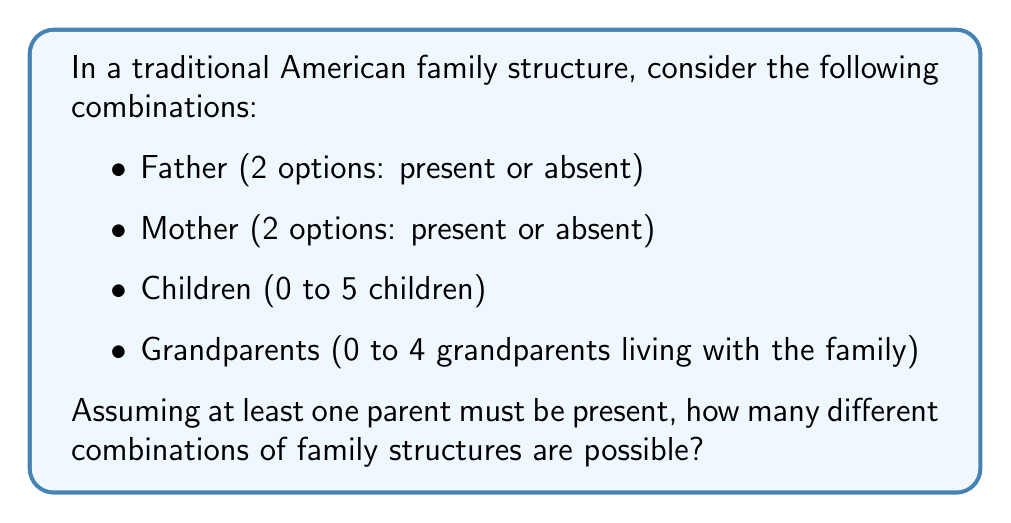Show me your answer to this math problem. Let's break this down step by step:

1) First, we need to consider the parent combinations:
   - Both parents present
   - Only father present
   - Only mother present
   This gives us 3 possible parent combinations.

2) For children, we have 6 possibilities (0 to 5 children):
   $${0, 1, 2, 3, 4, 5}$$

3) For grandparents, we have 5 possibilities (0 to 4 grandparents):
   $${0, 1, 2, 3, 4}$$

4) Now, we can use the multiplication principle. The total number of combinations is:
   $$\text{Parent combinations} \times \text{Child possibilities} \times \text{Grandparent possibilities}$$

5) Substituting the numbers:
   $$3 \times 6 \times 5 = 90$$

Therefore, there are 90 possible combinations of traditional American family structures based on the given criteria.
Answer: 90 combinations 